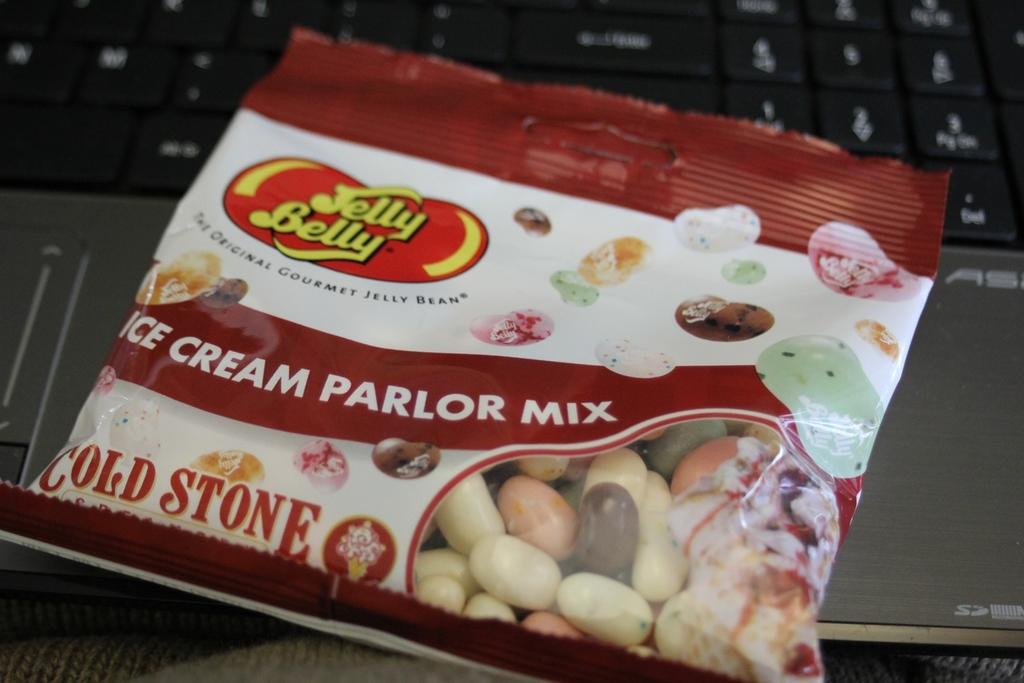What electronic device is present in the image? There is a laptop in the image. What colors can be seen on the laptop? The laptop is silver and black in color. What is placed on top of the laptop? There is a packet visible on the laptop. What colors are present on the packet? The packet is brown, white, red, and yellow in color. How many pies are being glued together in the image? There are no pies or glue present in the image. Is there a cast visible on the laptop? There is no cast visible in the image. 